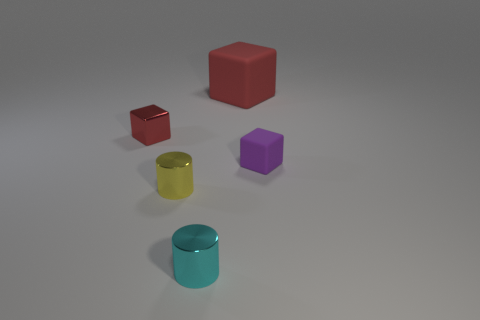Is there any other thing that has the same color as the small matte object?
Offer a terse response. No. What is the shape of the tiny yellow metallic thing?
Keep it short and to the point. Cylinder. What number of objects are both to the left of the red matte thing and on the right side of the small red shiny thing?
Offer a very short reply. 2. Do the big rubber thing and the shiny block have the same color?
Your response must be concise. Yes. There is another tiny object that is the same shape as the small red object; what material is it?
Ensure brevity in your answer.  Rubber. Are there the same number of small cyan metallic cylinders right of the purple rubber thing and small matte blocks in front of the big red cube?
Offer a terse response. No. Does the purple thing have the same material as the yellow cylinder?
Your response must be concise. No. What number of red objects are either tiny rubber spheres or rubber things?
Provide a short and direct response. 1. What number of other purple objects are the same shape as the big matte thing?
Your answer should be very brief. 1. What is the material of the large object?
Keep it short and to the point. Rubber. 